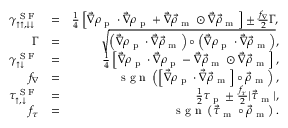<formula> <loc_0><loc_0><loc_500><loc_500>\begin{array} { r l r } { \gamma _ { \uparrow \uparrow , \downarrow \downarrow } ^ { S F } } & { = } & { \frac { 1 } { 4 } \left [ \vec { \nabla } \rho _ { p } \cdot \vec { \nabla } \rho _ { p } + \vec { \nabla } \vec { \rho } _ { m } \odot \vec { \nabla } \vec { \rho } _ { m } \right ] \pm \frac { f _ { \nabla } } { 2 } \Gamma , } \\ { \Gamma } & { = } & { \sqrt { \left ( \vec { \nabla } \rho _ { p } \cdot \vec { \nabla } \vec { \rho } _ { m } \right ) \circ \left ( \vec { \nabla } \rho _ { p } \cdot \vec { \nabla } \vec { \rho } _ { m } \right ) } , } \\ { \gamma _ { \uparrow \downarrow } ^ { S F } } & { = } & { \frac { 1 } { 4 } \left [ \vec { \nabla } \rho _ { p } \cdot \vec { \nabla } \rho _ { p } - \vec { \nabla } \vec { \rho } _ { m } \odot \vec { \nabla } \vec { \rho } _ { m } \right ] , } \\ { f _ { \nabla } } & { = } & { s g n \left ( \left [ \vec { \nabla } \rho _ { p } \cdot \vec { \nabla } \vec { \rho } _ { m } \right ] \circ \vec { \rho } _ { m } \right ) , } \\ { \tau _ { \uparrow , \downarrow } ^ { S F } } & { = } & { \frac { 1 } { 2 } \tau _ { p } \pm \frac { f _ { \tau } } { 2 } | \vec { \tau } _ { m } | , } \\ { f _ { \tau } } & { = } & { s g n \left ( \vec { \tau } _ { m } \circ \vec { \rho } _ { m } \right ) . } \end{array}</formula> 